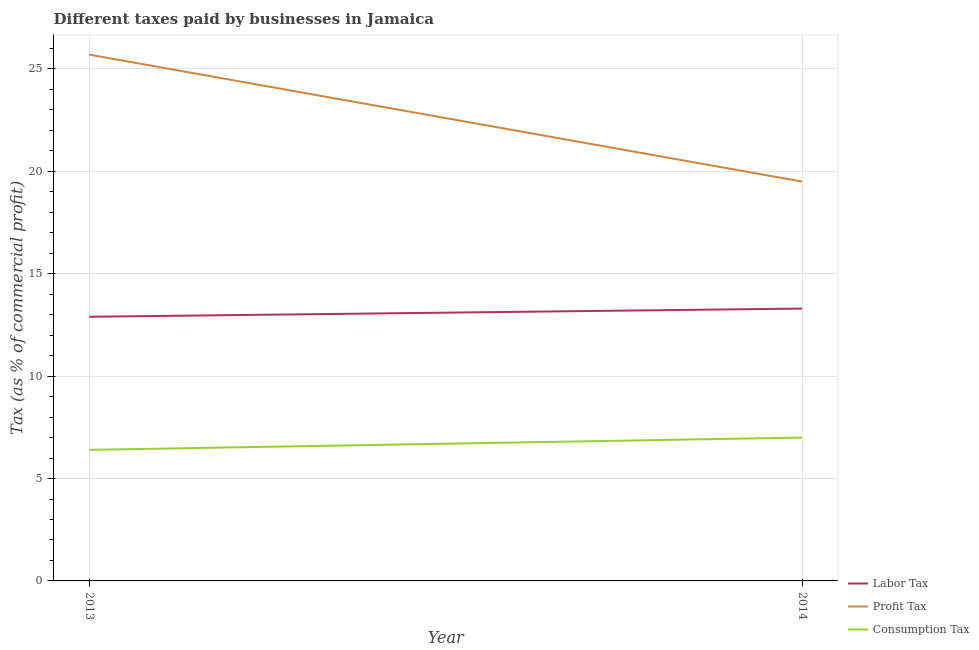Is the number of lines equal to the number of legend labels?
Make the answer very short. Yes. What is the percentage of profit tax in 2013?
Your answer should be very brief. 25.7. In which year was the percentage of consumption tax minimum?
Give a very brief answer. 2013. What is the total percentage of labor tax in the graph?
Offer a very short reply. 26.2. What is the difference between the percentage of consumption tax in 2013 and that in 2014?
Ensure brevity in your answer.  -0.6. What is the difference between the percentage of profit tax in 2013 and the percentage of labor tax in 2014?
Provide a short and direct response. 12.4. What is the average percentage of profit tax per year?
Your answer should be very brief. 22.6. In the year 2014, what is the difference between the percentage of consumption tax and percentage of profit tax?
Offer a terse response. -12.5. What is the ratio of the percentage of consumption tax in 2013 to that in 2014?
Ensure brevity in your answer.  0.91. Is the percentage of labor tax in 2013 less than that in 2014?
Your response must be concise. Yes. In how many years, is the percentage of labor tax greater than the average percentage of labor tax taken over all years?
Your answer should be very brief. 1. Is it the case that in every year, the sum of the percentage of labor tax and percentage of profit tax is greater than the percentage of consumption tax?
Give a very brief answer. Yes. Is the percentage of profit tax strictly greater than the percentage of consumption tax over the years?
Your response must be concise. Yes. Is the percentage of labor tax strictly less than the percentage of consumption tax over the years?
Your response must be concise. No. Are the values on the major ticks of Y-axis written in scientific E-notation?
Your answer should be very brief. No. Does the graph contain any zero values?
Your answer should be very brief. No. How many legend labels are there?
Provide a short and direct response. 3. What is the title of the graph?
Give a very brief answer. Different taxes paid by businesses in Jamaica. What is the label or title of the X-axis?
Keep it short and to the point. Year. What is the label or title of the Y-axis?
Offer a very short reply. Tax (as % of commercial profit). What is the Tax (as % of commercial profit) of Labor Tax in 2013?
Keep it short and to the point. 12.9. What is the Tax (as % of commercial profit) in Profit Tax in 2013?
Provide a short and direct response. 25.7. What is the Tax (as % of commercial profit) in Consumption Tax in 2013?
Offer a terse response. 6.4. What is the Tax (as % of commercial profit) of Labor Tax in 2014?
Your response must be concise. 13.3. What is the Tax (as % of commercial profit) of Consumption Tax in 2014?
Your answer should be compact. 7. Across all years, what is the maximum Tax (as % of commercial profit) in Labor Tax?
Your answer should be very brief. 13.3. Across all years, what is the maximum Tax (as % of commercial profit) of Profit Tax?
Offer a very short reply. 25.7. Across all years, what is the minimum Tax (as % of commercial profit) in Profit Tax?
Provide a short and direct response. 19.5. Across all years, what is the minimum Tax (as % of commercial profit) of Consumption Tax?
Provide a succinct answer. 6.4. What is the total Tax (as % of commercial profit) in Labor Tax in the graph?
Give a very brief answer. 26.2. What is the total Tax (as % of commercial profit) in Profit Tax in the graph?
Make the answer very short. 45.2. What is the average Tax (as % of commercial profit) in Profit Tax per year?
Ensure brevity in your answer.  22.6. What is the average Tax (as % of commercial profit) of Consumption Tax per year?
Ensure brevity in your answer.  6.7. In the year 2013, what is the difference between the Tax (as % of commercial profit) of Labor Tax and Tax (as % of commercial profit) of Profit Tax?
Your answer should be compact. -12.8. In the year 2013, what is the difference between the Tax (as % of commercial profit) of Labor Tax and Tax (as % of commercial profit) of Consumption Tax?
Make the answer very short. 6.5. In the year 2013, what is the difference between the Tax (as % of commercial profit) of Profit Tax and Tax (as % of commercial profit) of Consumption Tax?
Your response must be concise. 19.3. What is the ratio of the Tax (as % of commercial profit) in Labor Tax in 2013 to that in 2014?
Your answer should be very brief. 0.97. What is the ratio of the Tax (as % of commercial profit) of Profit Tax in 2013 to that in 2014?
Offer a terse response. 1.32. What is the ratio of the Tax (as % of commercial profit) of Consumption Tax in 2013 to that in 2014?
Keep it short and to the point. 0.91. What is the difference between the highest and the second highest Tax (as % of commercial profit) in Labor Tax?
Offer a terse response. 0.4. What is the difference between the highest and the second highest Tax (as % of commercial profit) of Profit Tax?
Offer a very short reply. 6.2. What is the difference between the highest and the lowest Tax (as % of commercial profit) in Consumption Tax?
Your response must be concise. 0.6. 